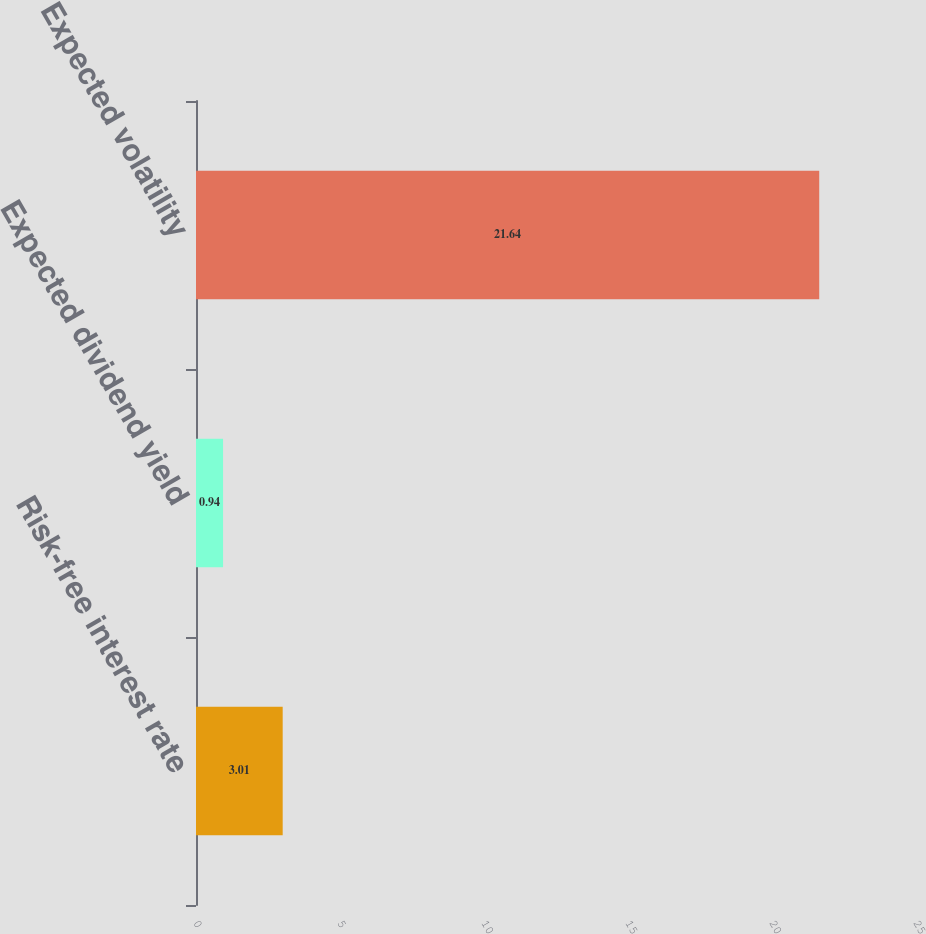Convert chart to OTSL. <chart><loc_0><loc_0><loc_500><loc_500><bar_chart><fcel>Risk-free interest rate<fcel>Expected dividend yield<fcel>Expected volatility<nl><fcel>3.01<fcel>0.94<fcel>21.64<nl></chart> 